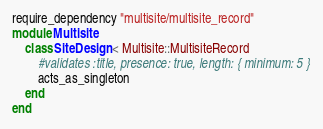<code> <loc_0><loc_0><loc_500><loc_500><_Ruby_>require_dependency "multisite/multisite_record"
module Multisite
	class SiteDesign < Multisite::MultisiteRecord
		#validates :title, presence: true, length: { minimum: 5 }
		acts_as_singleton
	end
end
</code> 